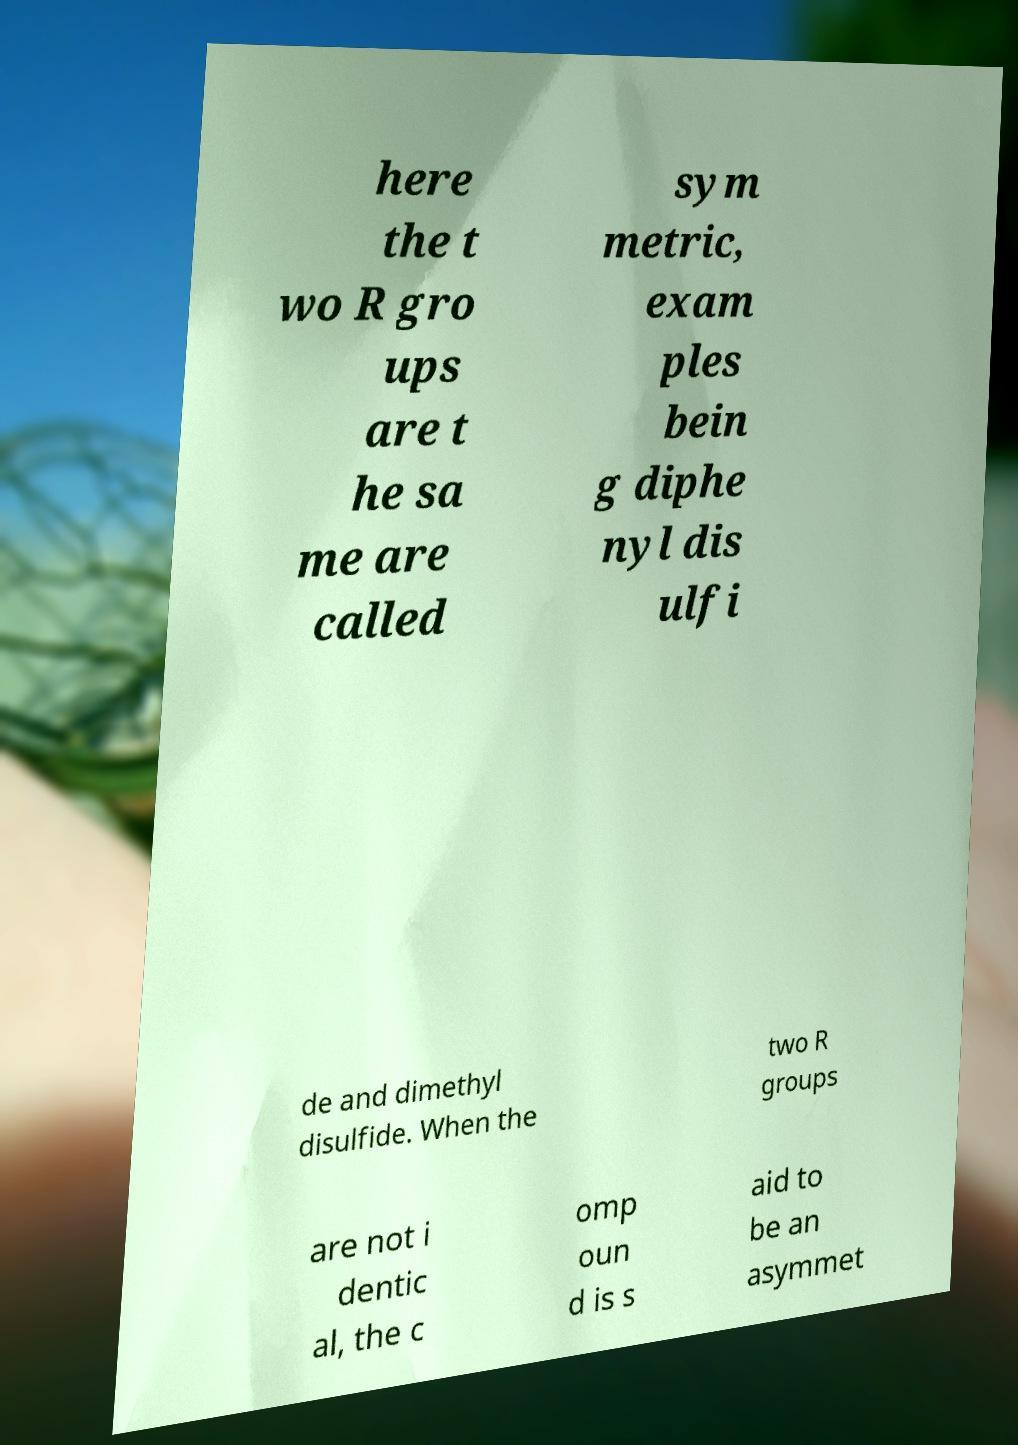Please identify and transcribe the text found in this image. here the t wo R gro ups are t he sa me are called sym metric, exam ples bein g diphe nyl dis ulfi de and dimethyl disulfide. When the two R groups are not i dentic al, the c omp oun d is s aid to be an asymmet 